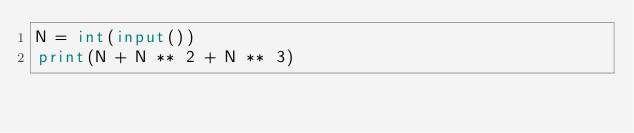<code> <loc_0><loc_0><loc_500><loc_500><_Python_>N = int(input())
print(N + N ** 2 + N ** 3)
</code> 